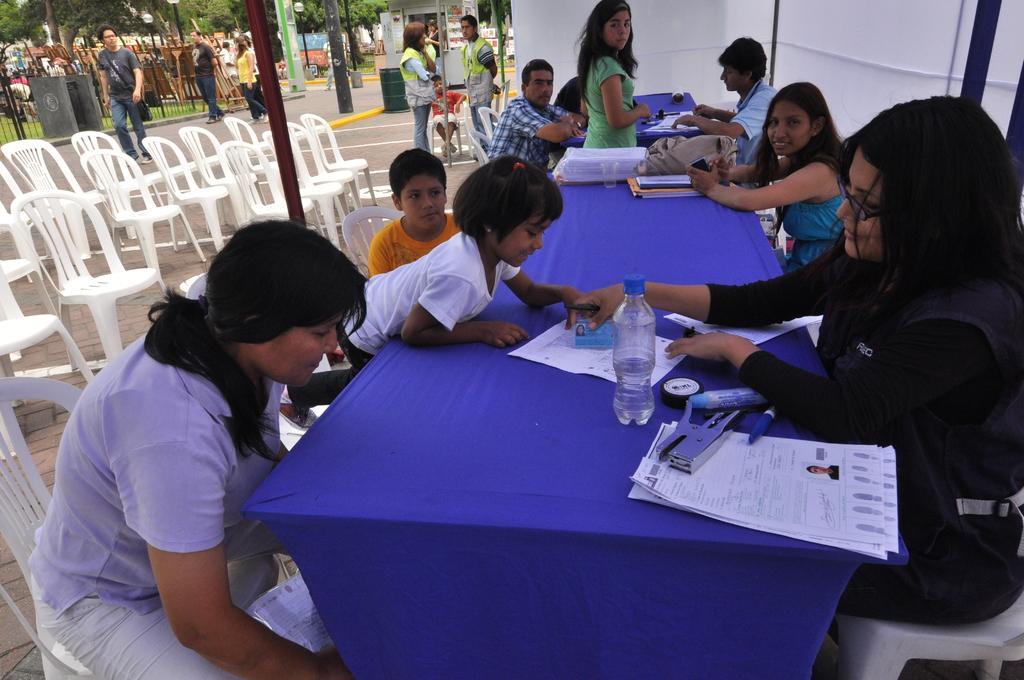How would you summarize this image in a sentence or two? This picture consists of table , on the table I can see a blue color cloth and papers and staplers and markers and bags and around the table I can see there are persons sitting on chair and on the left side I can see white color chairs and pole and fence and persons walking on road and trees visible at the top. 